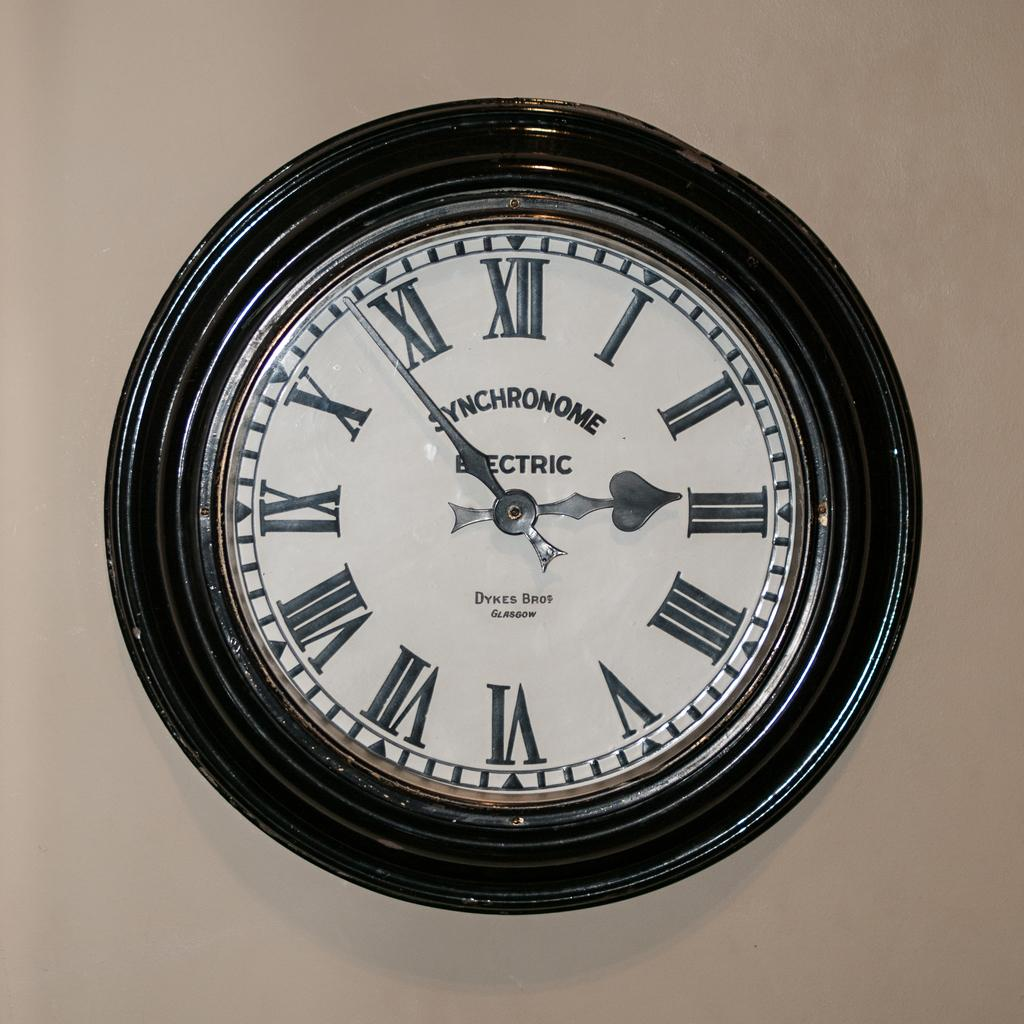<image>
Share a concise interpretation of the image provided. A wall mounted electric clock has Roman numerals on its face. 